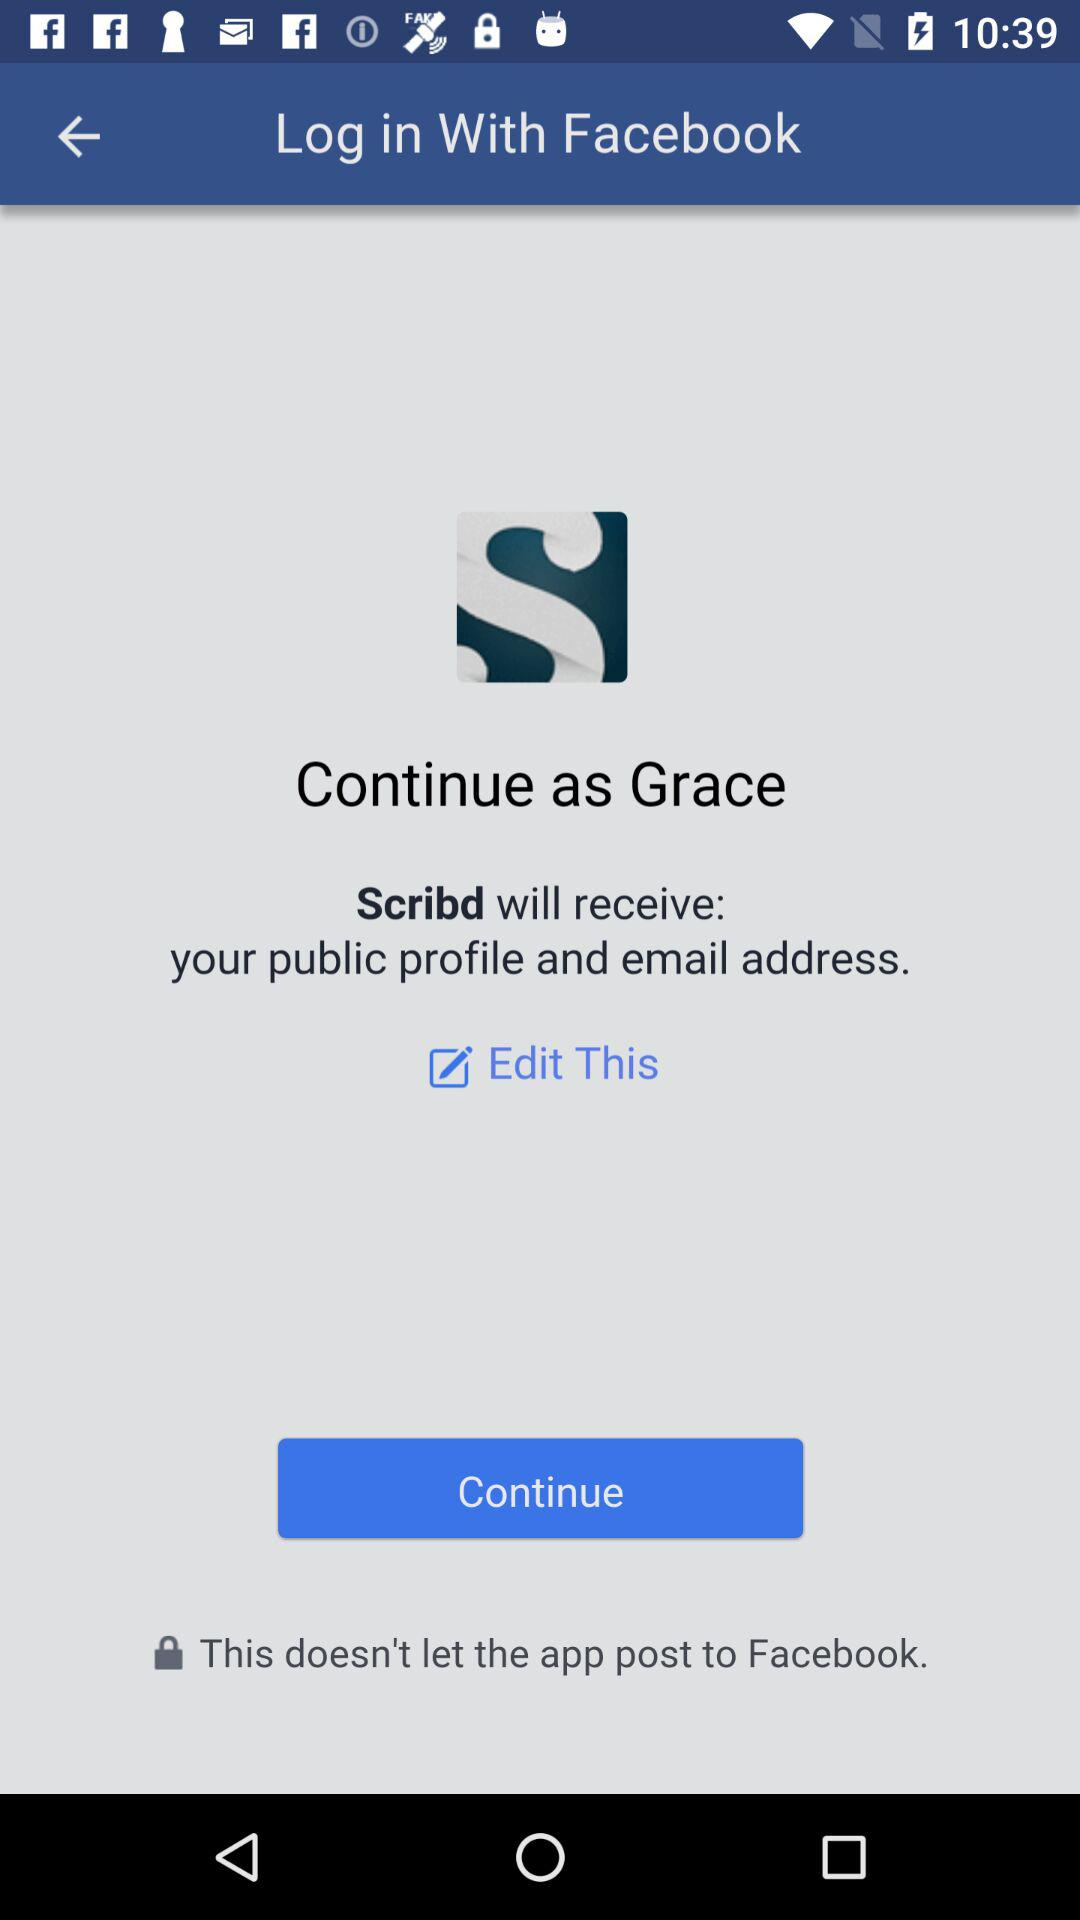What is the name of the user? The name of the user is Grace. 